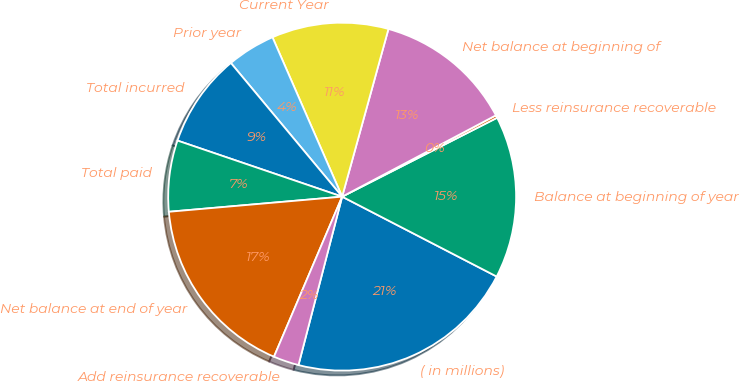<chart> <loc_0><loc_0><loc_500><loc_500><pie_chart><fcel>( in millions)<fcel>Balance at beginning of year<fcel>Less reinsurance recoverable<fcel>Net balance at beginning of<fcel>Current Year<fcel>Prior year<fcel>Total incurred<fcel>Total paid<fcel>Net balance at end of year<fcel>Add reinsurance recoverable<nl><fcel>21.45%<fcel>15.09%<fcel>0.25%<fcel>12.97%<fcel>10.85%<fcel>4.49%<fcel>8.73%<fcel>6.61%<fcel>17.21%<fcel>2.37%<nl></chart> 